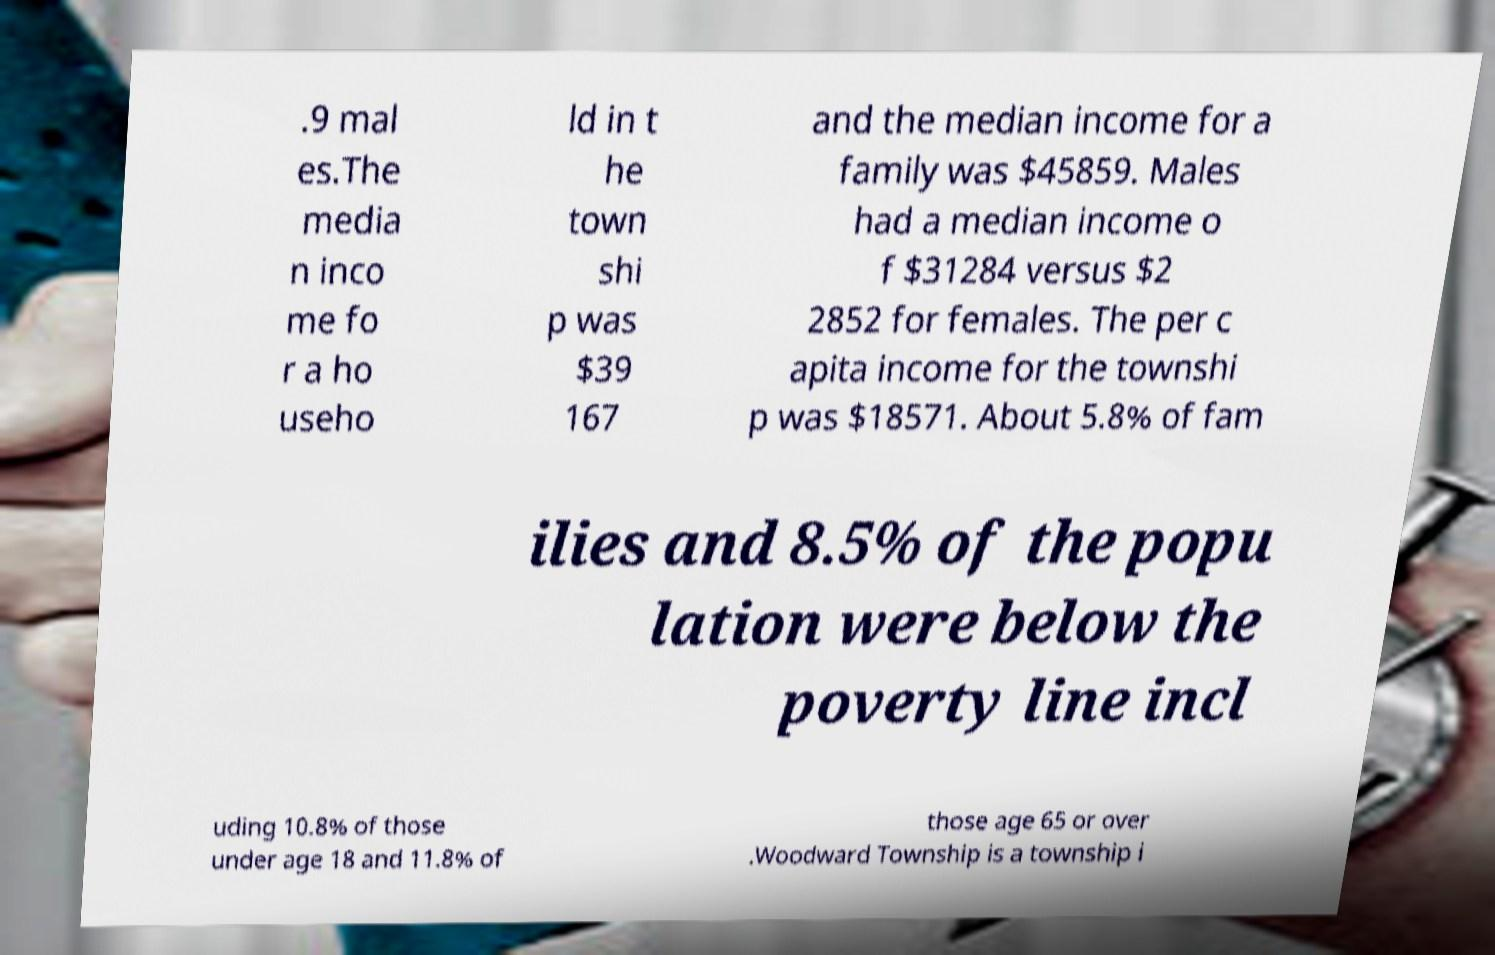I need the written content from this picture converted into text. Can you do that? .9 mal es.The media n inco me fo r a ho useho ld in t he town shi p was $39 167 and the median income for a family was $45859. Males had a median income o f $31284 versus $2 2852 for females. The per c apita income for the townshi p was $18571. About 5.8% of fam ilies and 8.5% of the popu lation were below the poverty line incl uding 10.8% of those under age 18 and 11.8% of those age 65 or over .Woodward Township is a township i 